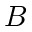<formula> <loc_0><loc_0><loc_500><loc_500>B</formula> 